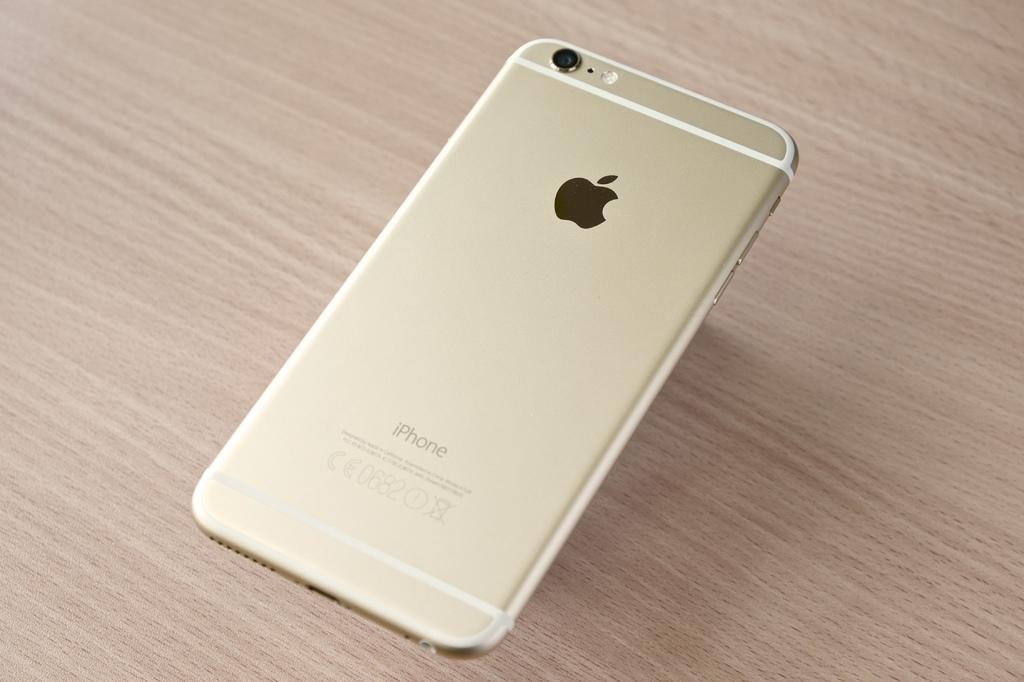<image>
Give a short and clear explanation of the subsequent image. A phone that has an apple logo on it 